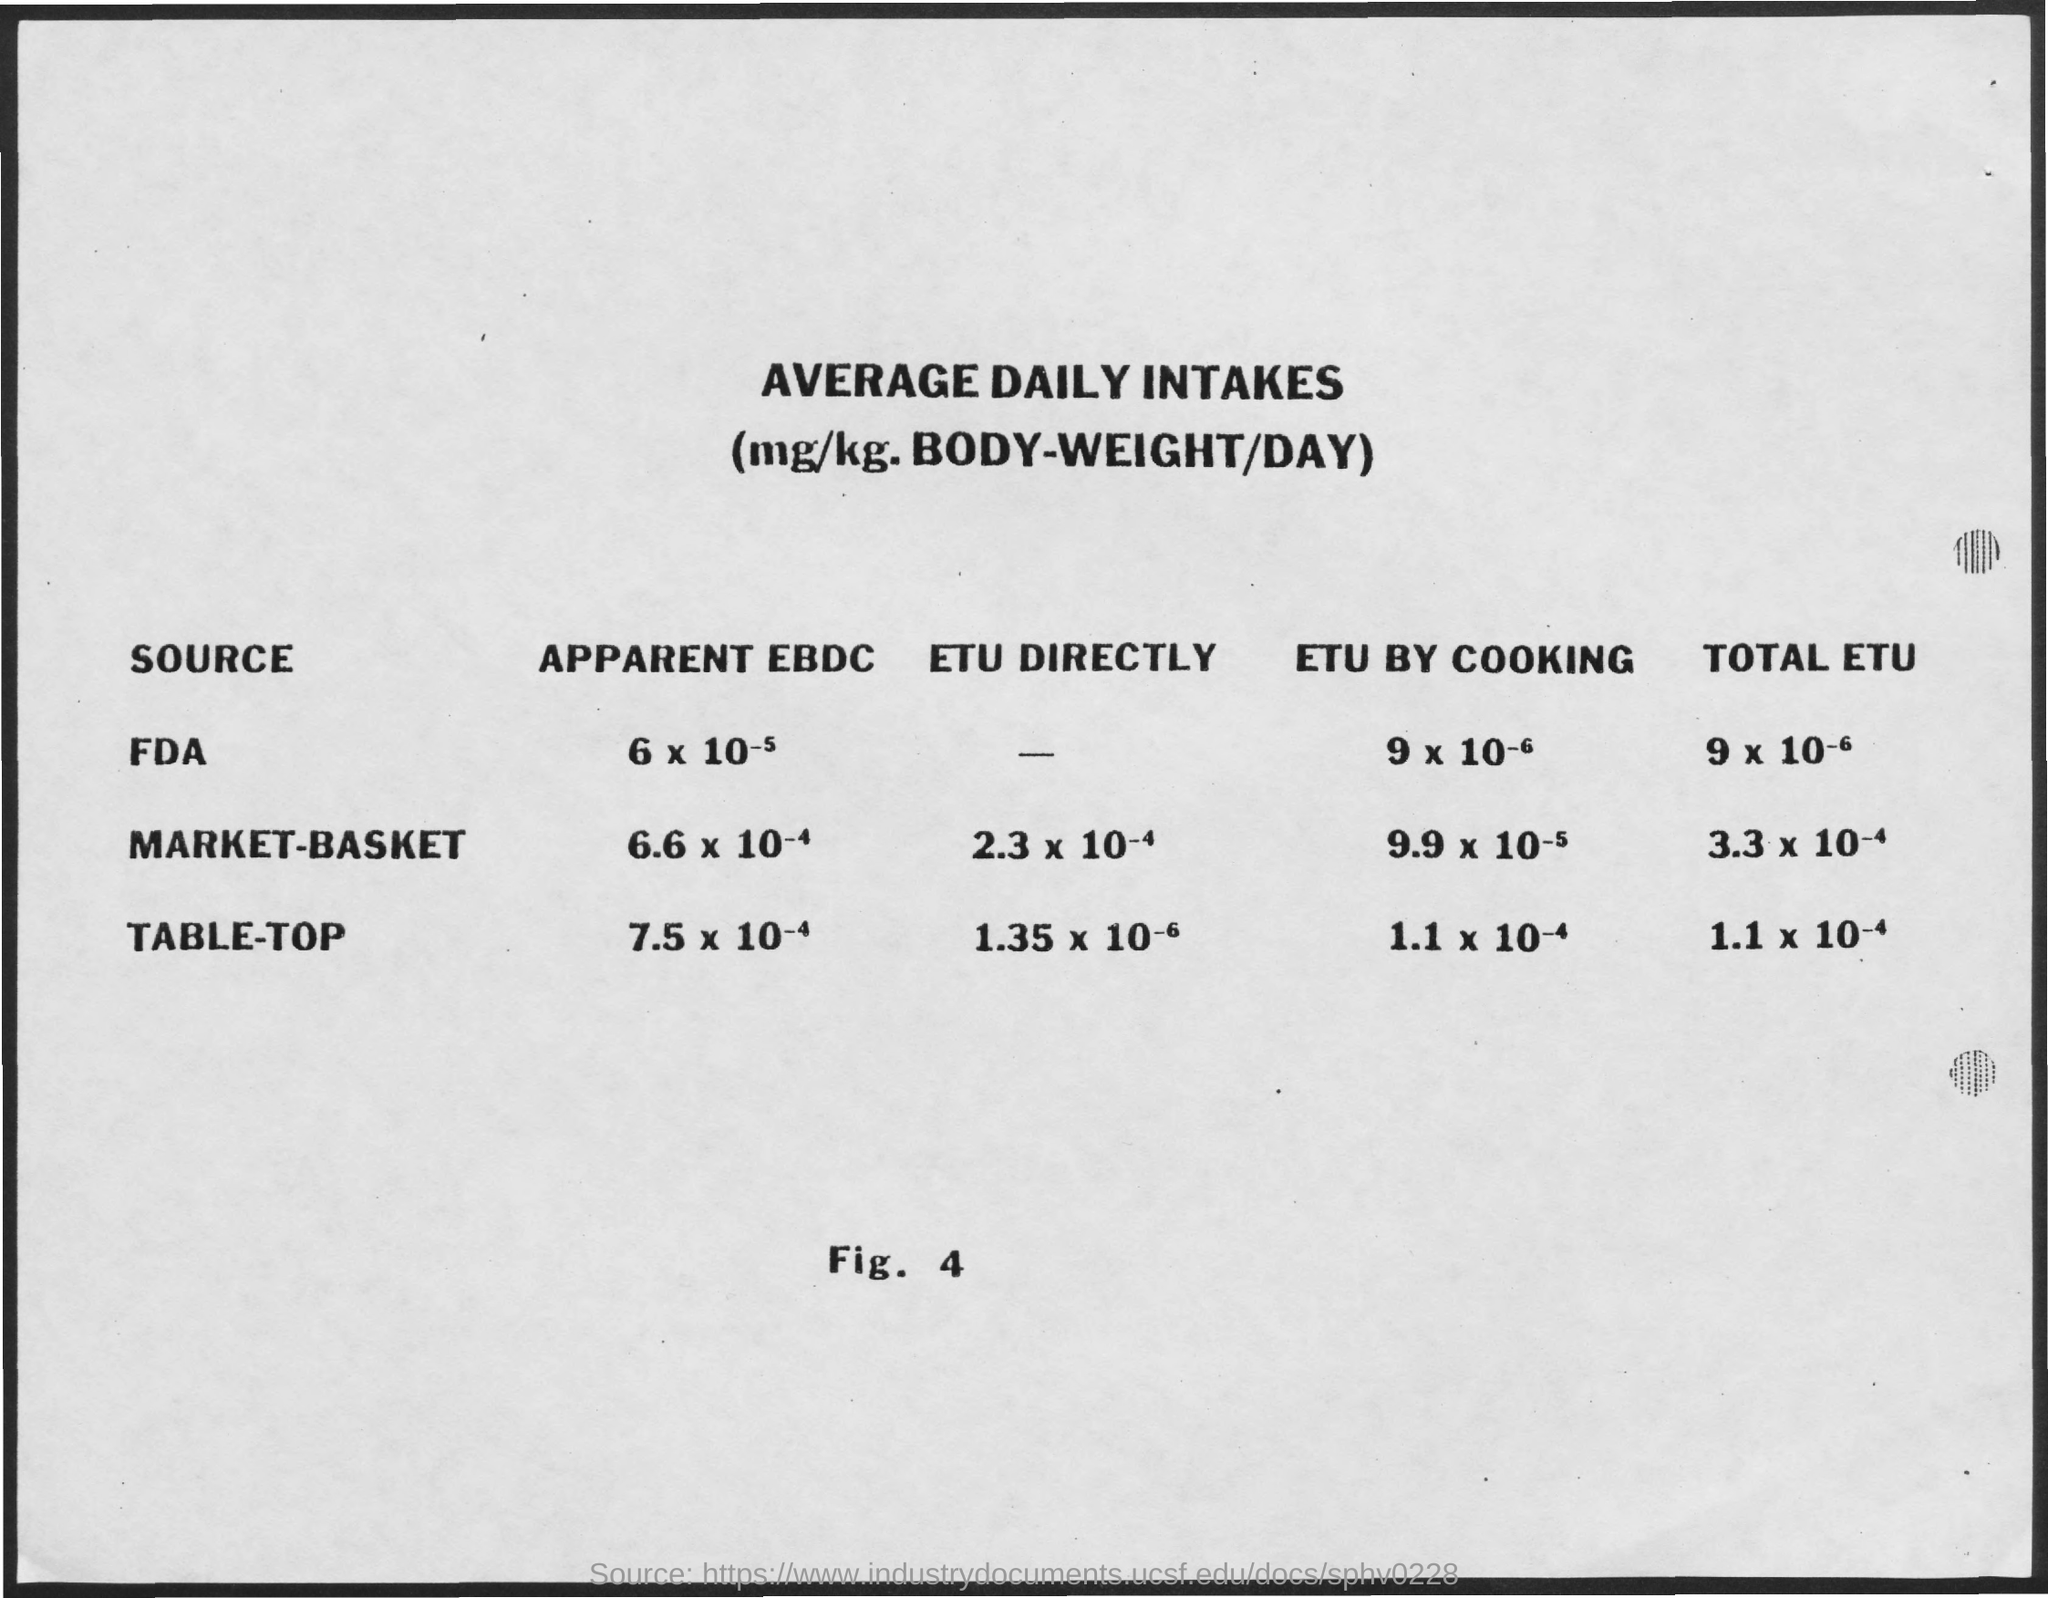What is the title of the document?
Offer a very short reply. Average daily intakes. 